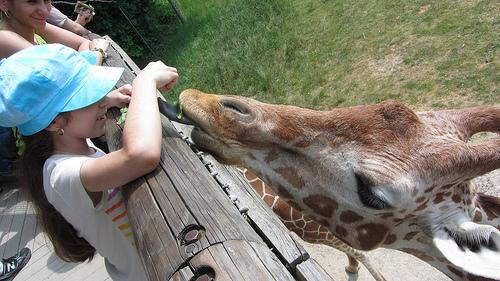Highlight the main subject, their clothing, and the action performed by them in the image. A girl in a blue hat is captured feeding a giraffe with an outstretched black tongue. Provide a short description of the primary character and their interaction with another subject in the image. A girl with long brown hair wearing a light blue cap feeds a giraffe with a black tongue sticking out. Mention the interaction of two main subjects in the image. A girl with long brown hair is feeding a leaf to a giraffe who has its black tongue sticking out. Write a concise overview of the primary activity and location in the image. A girl wearing a blue hat feeds a giraffe at a zoo exhibit with green grass and a wooden fence. In a sentence, describe the primary subject and their surrounding environment. A girl wearing a blue hat feeds a giraffe in a zoo exhibit with a wooden fence and green grass. Provide a brief description of the primary action taking place in the image. A little girl wearing a blue hat is feeding a giraffe with a long black tongue sticking out. Mention the primary subject, their attire, and any specific action they are performing in the image. A little girl wearing a blue cap is offering a leaf to a giraffe with its tongue outstretched. Summarize the primary action and the setting, focusing on the main characters. A girl wearing a light blue cap feeds a giraffe with a black tongue, standing near a wooden fence and green grass. State the main event occurring in the image and any notable details about the setting. In a zoo exhibit with green grass and wooden fence, a girl wearing a light blue cap is feeding a giraffe. Describe the foremost characters in the image and their actions. A little girl in a blue hat feeds a giraffe, who has a rust-colored spot and a black tongue extended towards the leaf she offers. 